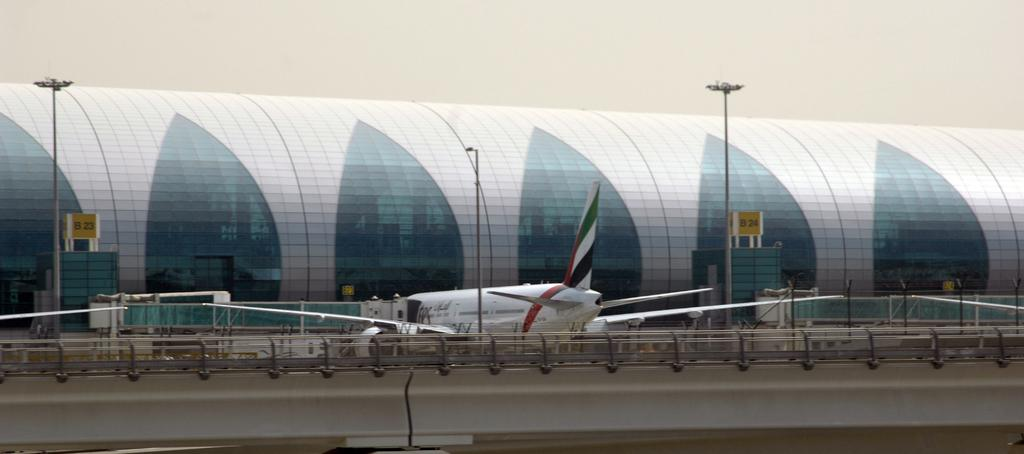What type of building is in the image? There is a glass building in the image. What colors are present on the building? The building has white and blue colors. What objects can be seen in the image besides the building? There are boards, light poles, an aircraft, and fencing in the image. What type of prose can be heard coming from the building in the image? There is no indication of any prose or sound in the image, as it is a still image of a building and its surroundings. 